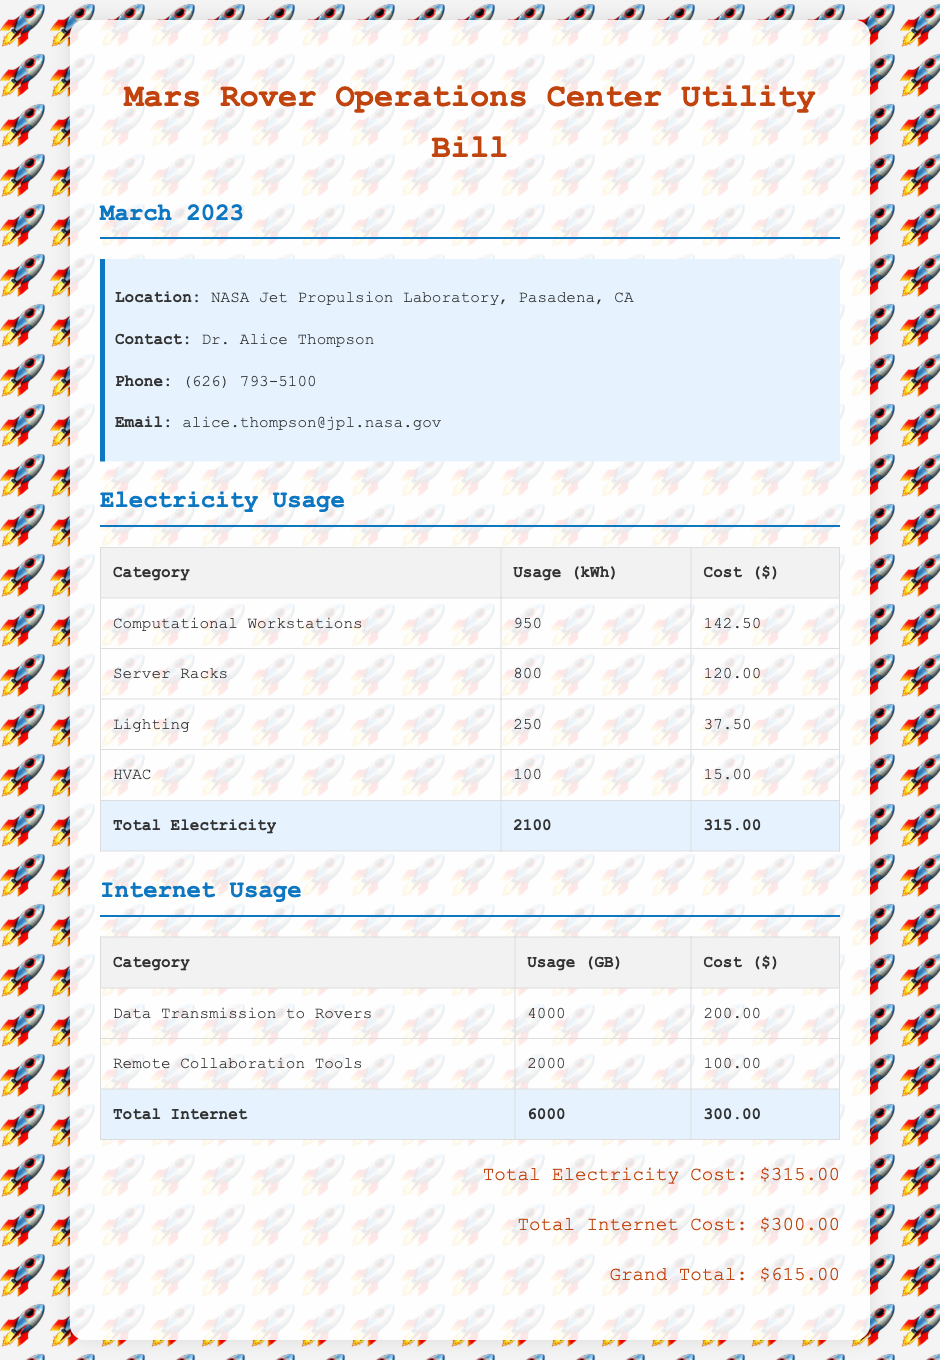What is the total electricity cost? The total electricity cost is listed at the bottom of the electricity usage section, which is $315.00.
Answer: $315.00 How much was spent on server racks? The cost for server racks is provided in the electricity usage table, which is $120.00.
Answer: $120.00 What is the total internet data usage? The total internet data usage is given in the internet usage table, which sums to 6000 GB.
Answer: 6000 GB Who is the contact person for the utility bill? The contact person can be found in the contact information section, which is Dr. Alice Thompson.
Answer: Dr. Alice Thompson What is the grand total? The grand total is provided at the end of the document, which includes both electricity and internet costs, equaling $615.00.
Answer: $615.00 Which category used the most electricity? By comparing usage in the electricity table, 'Computational Workstations' used the most electricity at 950 kWh.
Answer: Computational Workstations How much was spent on data transmission to rovers? The cost for data transmission can be found in the internet usage table, which is $200.00.
Answer: $200.00 What month does this bill cover? The month covered by the bill is mentioned in the document's title and header section, which is March 2023.
Answer: March 2023 What was the HVAC usage in kWh? The HVAC usage figure is in the electricity table, which lists it as 100 kWh.
Answer: 100 kWh 